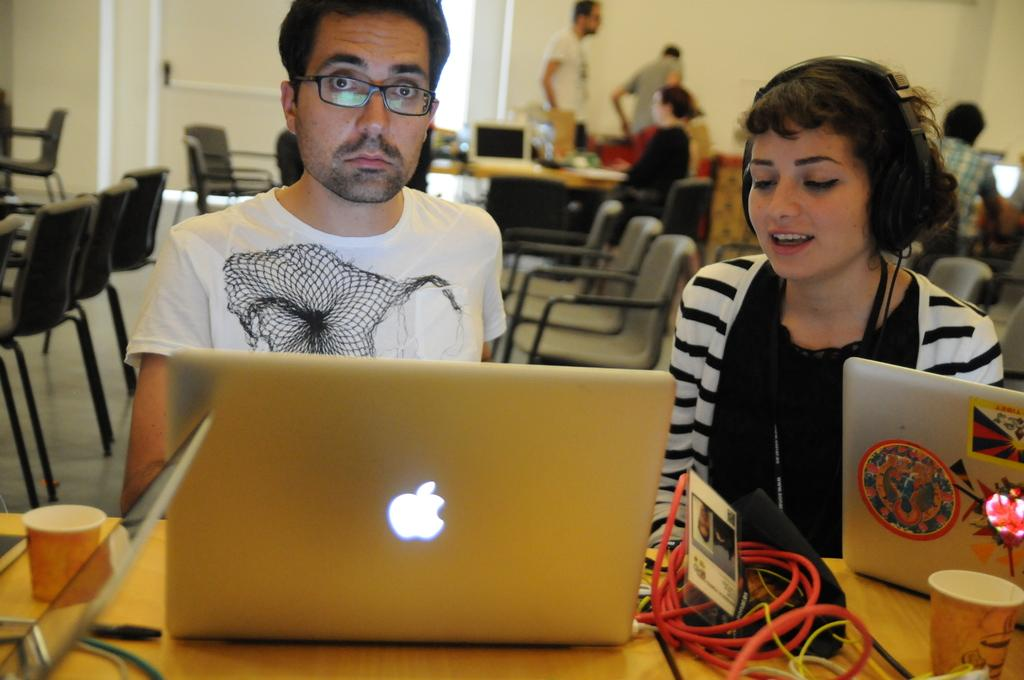What objects are on the desk in the image? There are laptops and glasses on the desk in the image. How many people are visible in the image? There are 2 people in the image. What is located behind the people? There are chairs behind the people. Are there any other people in the image? Yes, there are other people behind the chairs. What fact can be seen causing anger in the image? There is no indication of anger or any specific fact causing it in the image. 